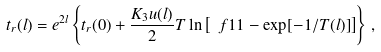<formula> <loc_0><loc_0><loc_500><loc_500>t _ { r } ( l ) = e ^ { 2 l } \left \{ t _ { r } ( 0 ) + \frac { K _ { 3 } u ( l ) } { 2 } T \ln { \left [ \ f { 1 } { 1 - \exp [ - 1 / T ( l ) ] } \right ] } \right \} \, ,</formula> 